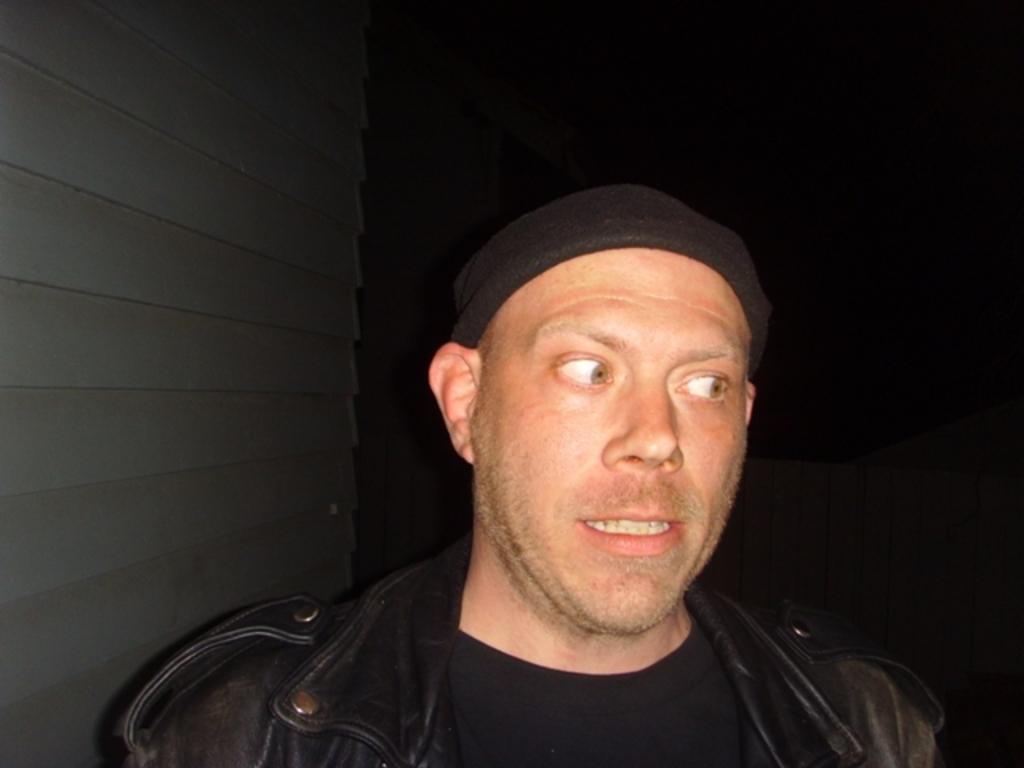Can you describe this image briefly? In this image I see a man who is wearing black jacket and black t-shirt and I see that he is wearing black cap and it is dark in the background. 